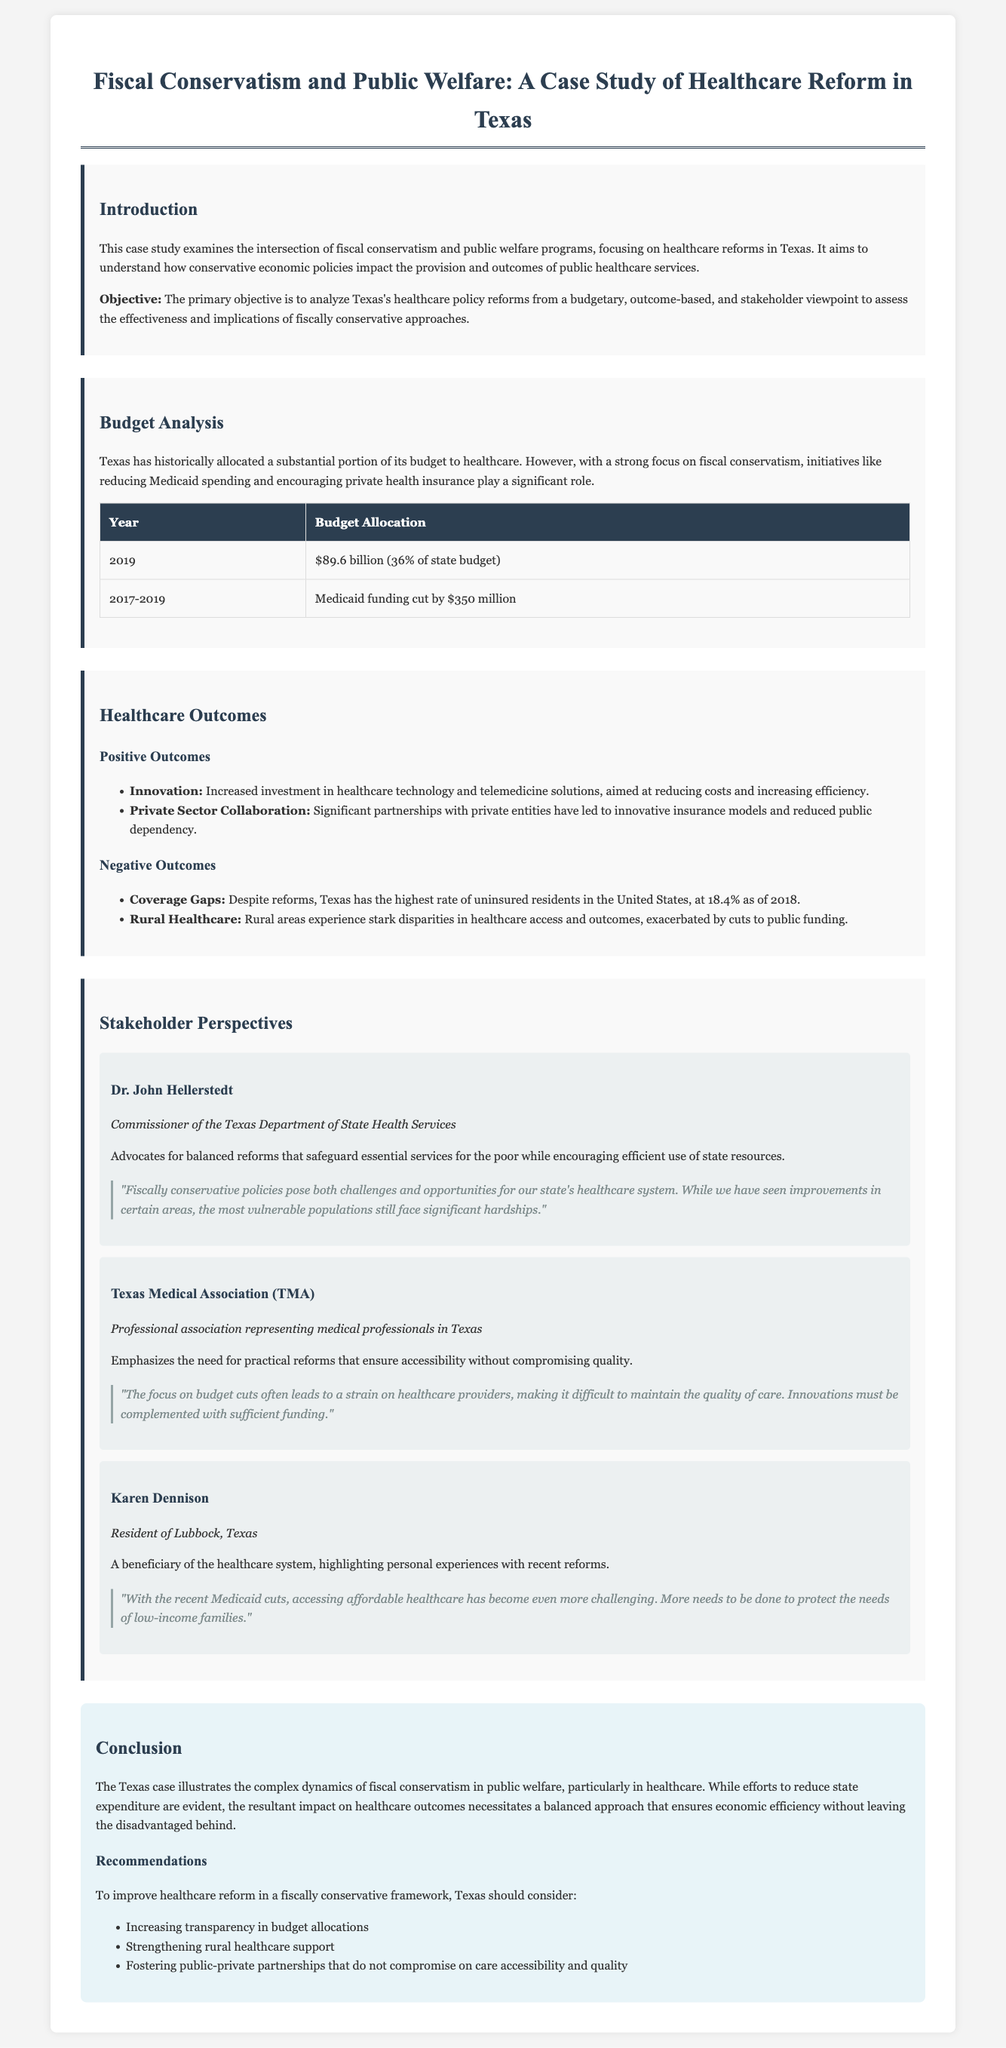what is the title of the case study? The title of the case study is stated prominently at the top of the document.
Answer: Fiscal Conservatism and Public Welfare: A Case Study of Healthcare Reform in Texas what percentage of the Texas state budget was allocated to healthcare in 2019? The document specifies the budget allocation percentage for healthcare in Texas for the year 2019.
Answer: 36% how much funding was cut from Medicaid during 2017-2019? The document provides specific information regarding Medicaid funding cuts in the specified period.
Answer: $350 million what is the uninsured rate in Texas as of 2018? The case study notes the rate of uninsured residents in Texas as of 2018.
Answer: 18.4% who is the Commissioner of the Texas Department of State Health Services? The document mentions the individual holding this position, providing their full name and title.
Answer: Dr. John Hellerstedt what did the Texas Medical Association emphasize regarding budget cuts? The document includes a direct quote summarizing the emphasis of the Texas Medical Association on this issue.
Answer: Strain on healthcare providers what innovative solution increased due to healthcare reforms? The document lists innovation in a specific area as one of the positive outcomes of healthcare reforms in Texas.
Answer: Healthcare technology and telemedicine solutions what are the recommendations for improving healthcare reform in Texas? The conclusions section lists specific recommendations aimed at improving healthcare reform.
Answer: Increasing transparency in budget allocations, strengthening rural healthcare support, fostering public-private partnerships 